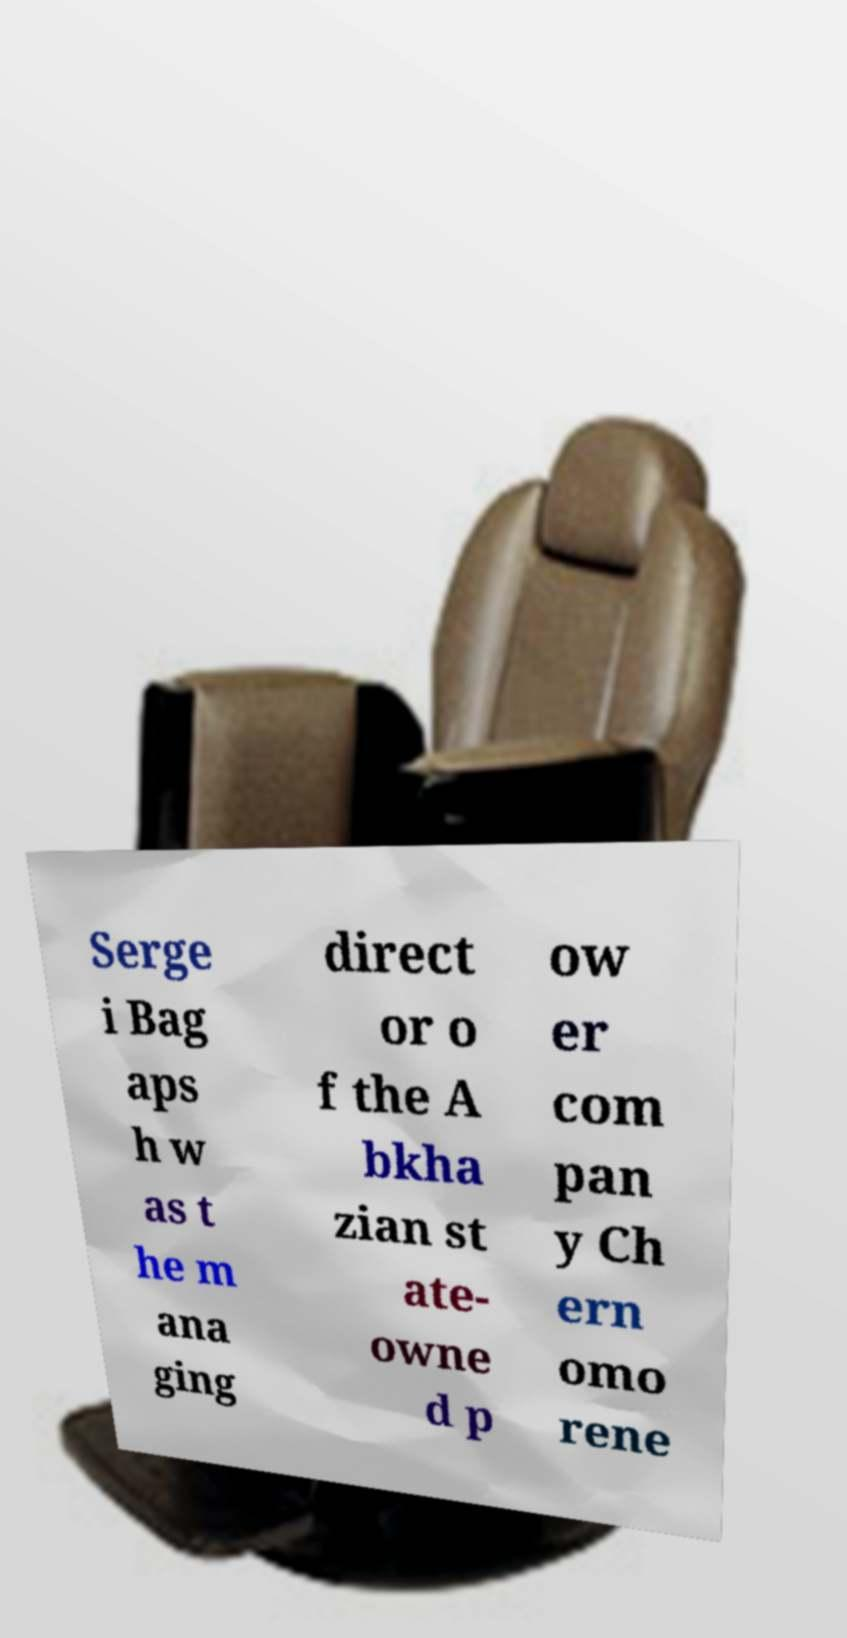There's text embedded in this image that I need extracted. Can you transcribe it verbatim? Serge i Bag aps h w as t he m ana ging direct or o f the A bkha zian st ate- owne d p ow er com pan y Ch ern omo rene 